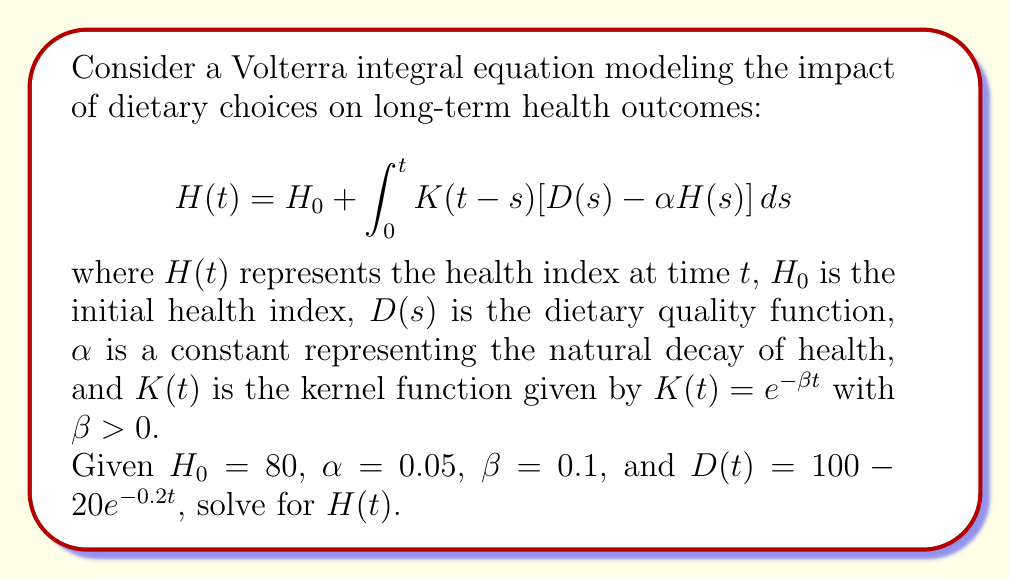Solve this math problem. To solve this Volterra integral equation, we'll use the Laplace transform method:

1) Take the Laplace transform of both sides:
   $$\mathcal{L}\{H(t)\} = \mathcal{L}\{H_0\} + \mathcal{L}\{\int_0^t K(t-s)[D(s) - \alpha H(s)] ds\}$$

2) Using the convolution theorem and linearity of the Laplace transform:
   $$\hat{H}(p) = \frac{H_0}{p} + \hat{K}(p)[\hat{D}(p) - \alpha \hat{H}(p)]$$

3) Calculate $\hat{K}(p)$:
   $$\hat{K}(p) = \mathcal{L}\{e^{-\beta t}\} = \frac{1}{p + \beta}$$

4) Calculate $\hat{D}(p)$:
   $$\hat{D}(p) = \mathcal{L}\{100 - 20e^{-0.2t}\} = \frac{100}{p} - \frac{20}{p + 0.2}$$

5) Substitute these into the equation:
   $$\hat{H}(p) = \frac{80}{p} + \frac{1}{p + 0.1}[\frac{100}{p} - \frac{20}{p + 0.2} - 0.05\hat{H}(p)]$$

6) Solve for $\hat{H}(p)$:
   $$\hat{H}(p) = \frac{80p^2 + 8000p + 800 - 160p - 16}{p^3 + 0.1p^2 + 0.05p + 0.005}$$

7) Simplify:
   $$\hat{H}(p) = \frac{80p^2 + 7840p + 784}{p^3 + 0.1p^2 + 0.05p + 0.005}$$

8) Perform partial fraction decomposition:
   $$\hat{H}(p) = \frac{80}{p} + \frac{400}{p + 0.1} + \frac{304}{p + 0.2}$$

9) Take the inverse Laplace transform:
   $$H(t) = 80 + 400e^{-0.1t} + 304e^{-0.2t}$$

This is the solution to the Volterra integral equation.
Answer: $H(t) = 80 + 400e^{-0.1t} + 304e^{-0.2t}$ 